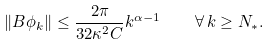<formula> <loc_0><loc_0><loc_500><loc_500>\| B \phi _ { k } \| \leq \frac { 2 \pi } { 3 2 \kappa ^ { 2 } C } k ^ { \alpha - 1 } \quad \forall \, k \geq N _ { * } .</formula> 